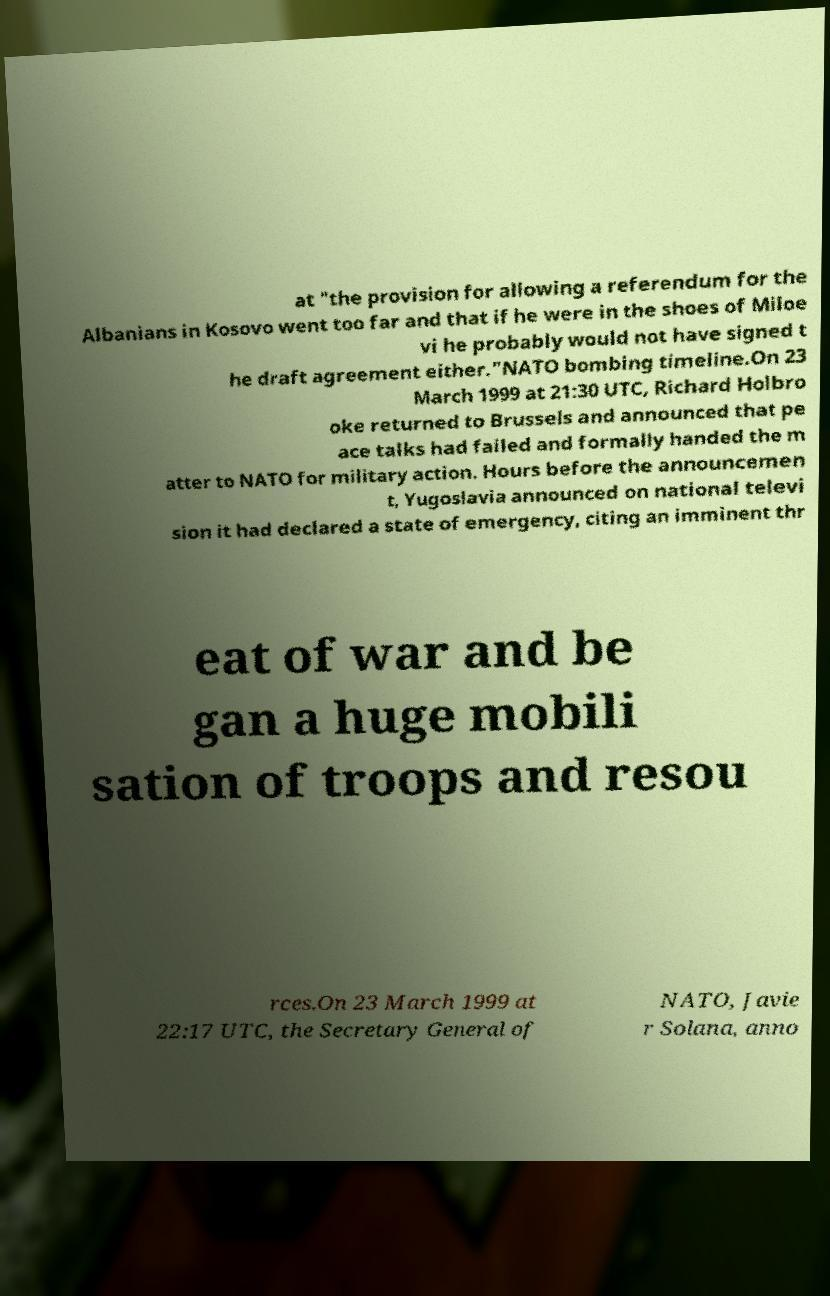Please identify and transcribe the text found in this image. at "the provision for allowing a referendum for the Albanians in Kosovo went too far and that if he were in the shoes of Miloe vi he probably would not have signed t he draft agreement either."NATO bombing timeline.On 23 March 1999 at 21:30 UTC, Richard Holbro oke returned to Brussels and announced that pe ace talks had failed and formally handed the m atter to NATO for military action. Hours before the announcemen t, Yugoslavia announced on national televi sion it had declared a state of emergency, citing an imminent thr eat of war and be gan a huge mobili sation of troops and resou rces.On 23 March 1999 at 22:17 UTC, the Secretary General of NATO, Javie r Solana, anno 